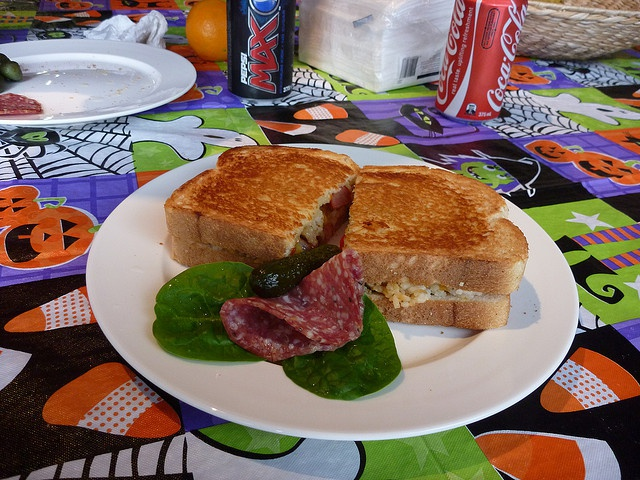Describe the objects in this image and their specific colors. I can see dining table in black, darkgray, brown, and lightgray tones, sandwich in purple, brown, black, maroon, and gray tones, bowl in purple, darkgray, and gray tones, bottle in purple, black, brown, navy, and gray tones, and orange in purple, red, orange, black, and maroon tones in this image. 